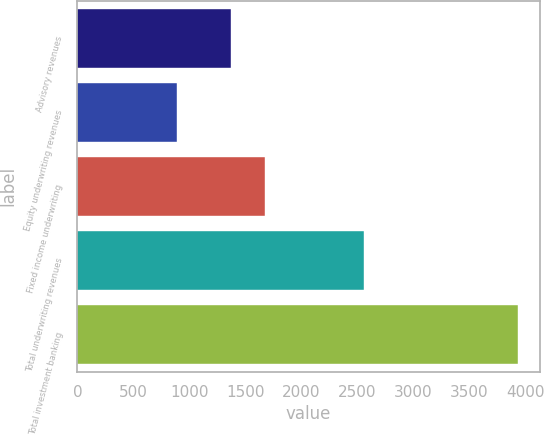Convert chart. <chart><loc_0><loc_0><loc_500><loc_500><bar_chart><fcel>Advisory revenues<fcel>Equity underwriting revenues<fcel>Fixed income underwriting<fcel>Total underwriting revenues<fcel>Total investment banking<nl><fcel>1369<fcel>892<fcel>1672.8<fcel>2561<fcel>3930<nl></chart> 